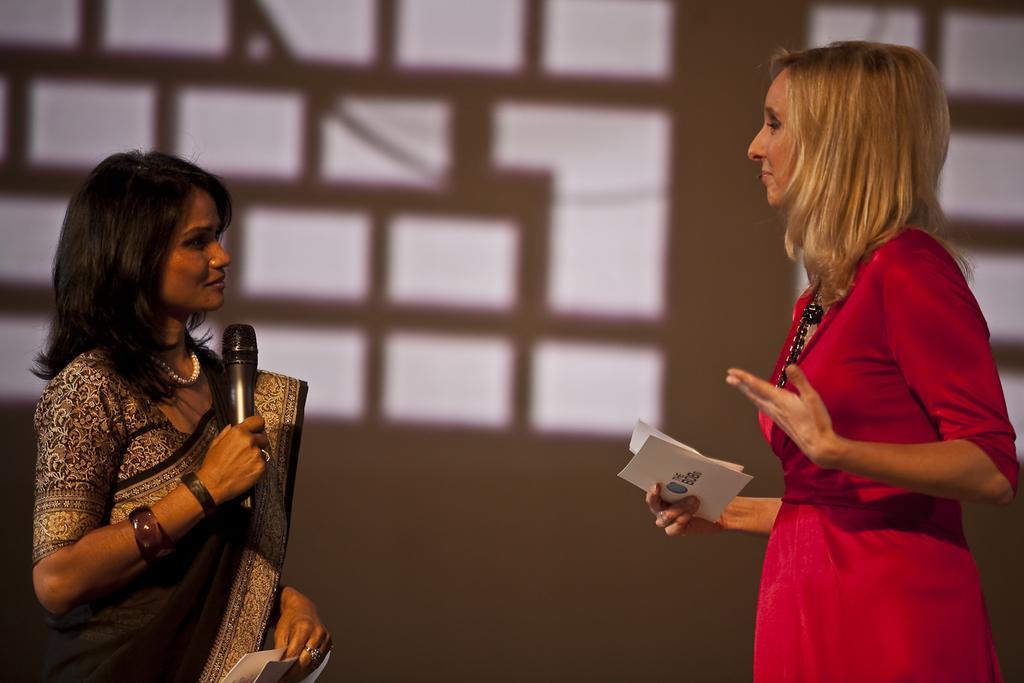How would you summarize this image in a sentence or two? In this picture there are two women, a woman in the left side, she is wearing a black saree and holding a mike in one hand and papers in another hand. Towards the right there is another woman, she is wearing a red dress and holding papers in one hand. In the background there is a wall. 